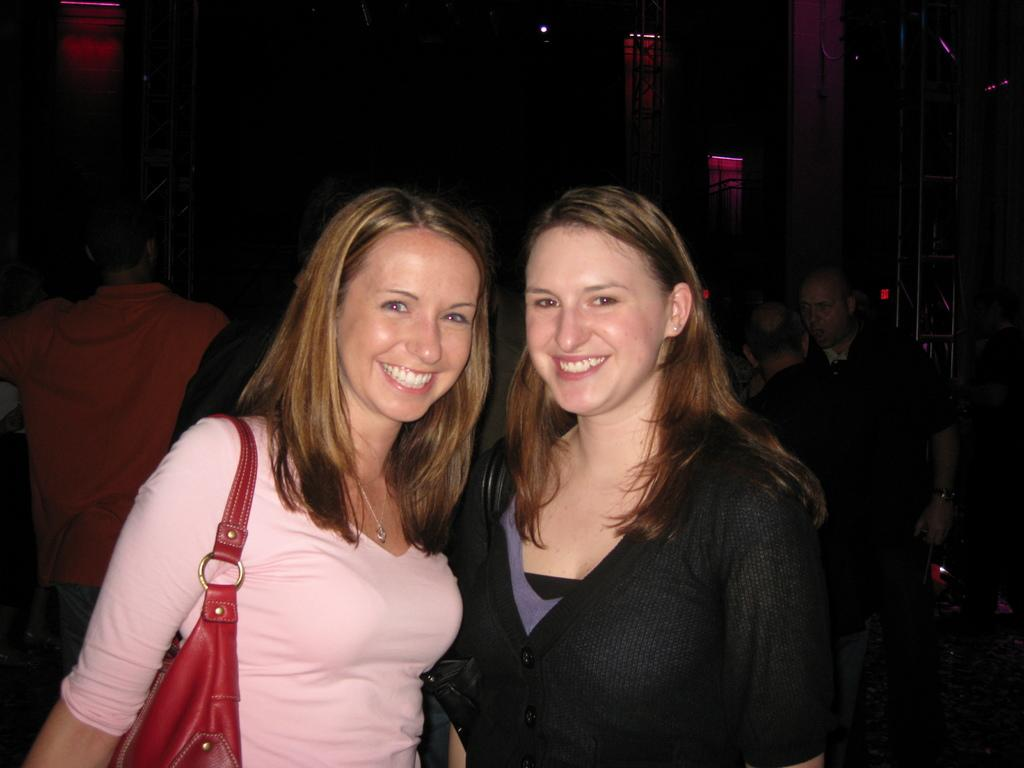How many women are in the image? There are two women in the image. What are the women doing in the image? The women are standing in front in the image. Are there any other people visible in the image? Yes, there are people standing at the back in the image. What type of joke is the woman on the left telling in the image? There is no indication in the image that the women are telling jokes or engaging in humor. 